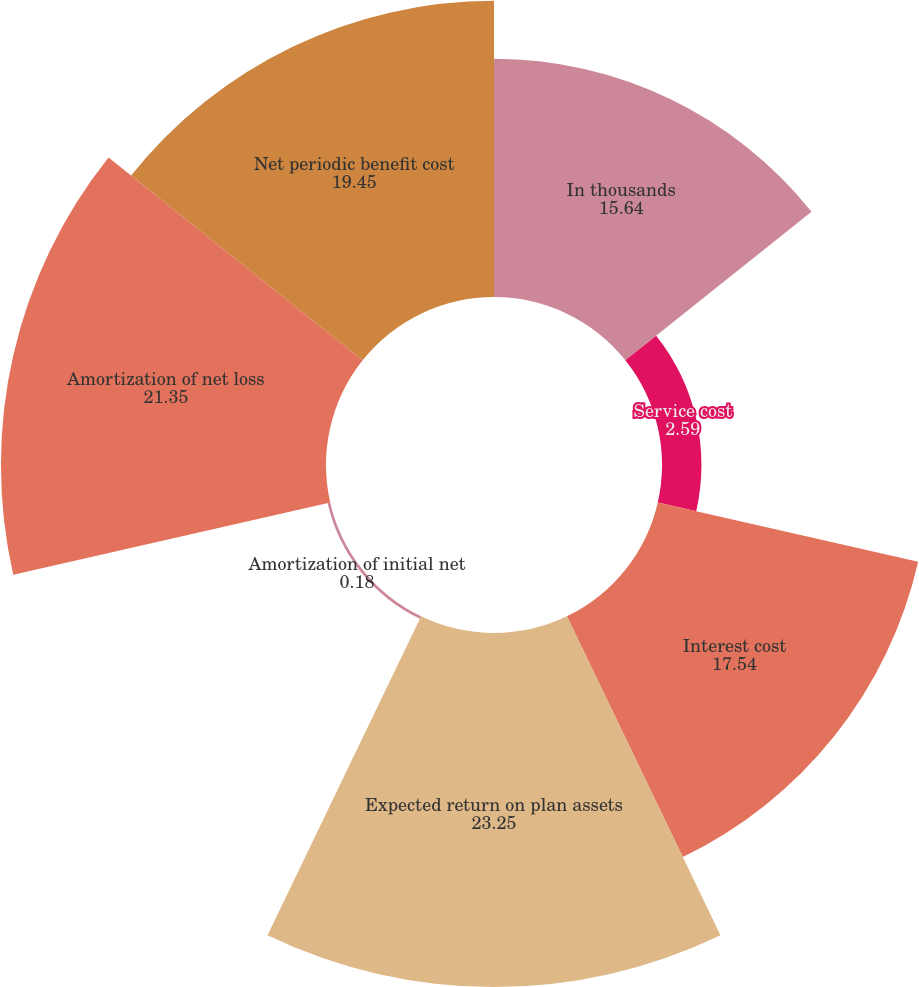<chart> <loc_0><loc_0><loc_500><loc_500><pie_chart><fcel>In thousands<fcel>Service cost<fcel>Interest cost<fcel>Expected return on plan assets<fcel>Amortization of initial net<fcel>Amortization of net loss<fcel>Net periodic benefit cost<nl><fcel>15.64%<fcel>2.59%<fcel>17.54%<fcel>23.25%<fcel>0.18%<fcel>21.35%<fcel>19.45%<nl></chart> 